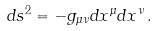Convert formula to latex. <formula><loc_0><loc_0><loc_500><loc_500>d s ^ { 2 } = - g _ { \mu \nu } d x ^ { \mu } d x ^ { \nu } \, .</formula> 